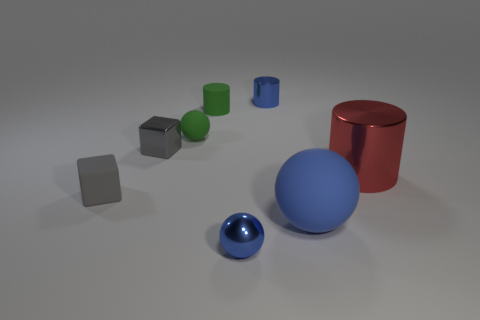Can you describe the lighting and shadows in the image? The image exhibits soft, diffuse lighting that casts gentle shadows under and to the sides of the objects. The lighter shadows suggest an overhead light source, possibly to the right of the frame, accentuating the three-dimensional forms of the objects. Could the arrangement of these objects be meaningful in any way? The objects appear to be deliberately arrayed to demonstrate perspective and depth, with their varying sizes, positions, and colors creating a visually stimulating composition that draws the eye from the foreground to the background. 